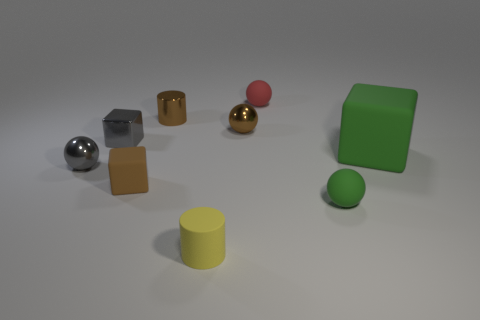There is a brown cylinder that is the same size as the red matte object; what is it made of?
Provide a succinct answer. Metal. There is a tiny gray object that is behind the tiny gray metallic ball; is its shape the same as the big rubber object?
Offer a very short reply. Yes. Is the color of the tiny shiny cylinder the same as the big rubber cube?
Keep it short and to the point. No. What number of things are either small things that are in front of the tiny green ball or small red metallic things?
Provide a succinct answer. 1. There is a brown shiny thing that is the same size as the brown metallic ball; what is its shape?
Provide a short and direct response. Cylinder. There is a red matte ball that is behind the yellow cylinder; is its size the same as the green rubber thing that is in front of the tiny brown rubber block?
Ensure brevity in your answer.  Yes. What color is the small cylinder that is made of the same material as the tiny red thing?
Your answer should be very brief. Yellow. Are the object that is behind the small metallic cylinder and the tiny cylinder that is behind the small rubber cylinder made of the same material?
Ensure brevity in your answer.  No. Are there any green matte blocks of the same size as the shiny block?
Ensure brevity in your answer.  No. There is a brown metal object to the left of the metal sphere that is behind the green rubber cube; how big is it?
Your answer should be very brief. Small. 